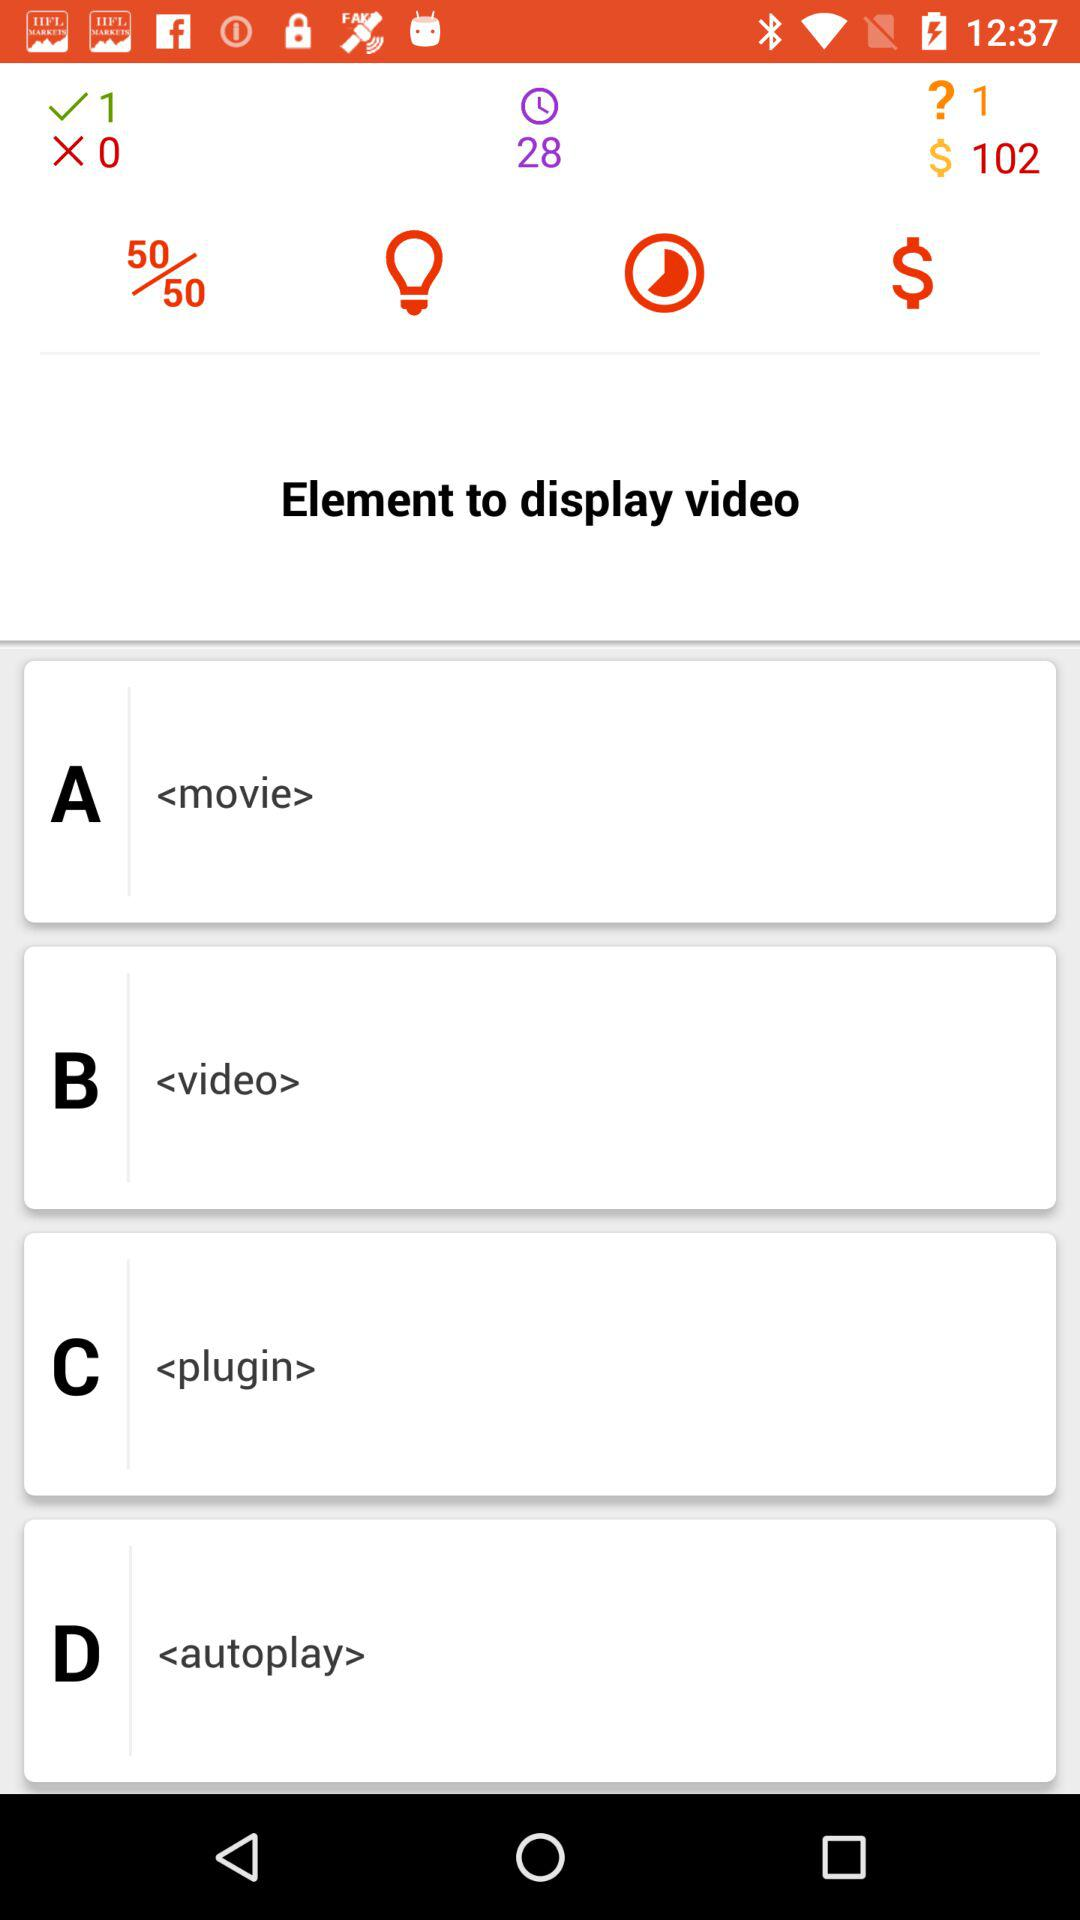How many seconds are left to answer the questions? There are 28 seconds left. 